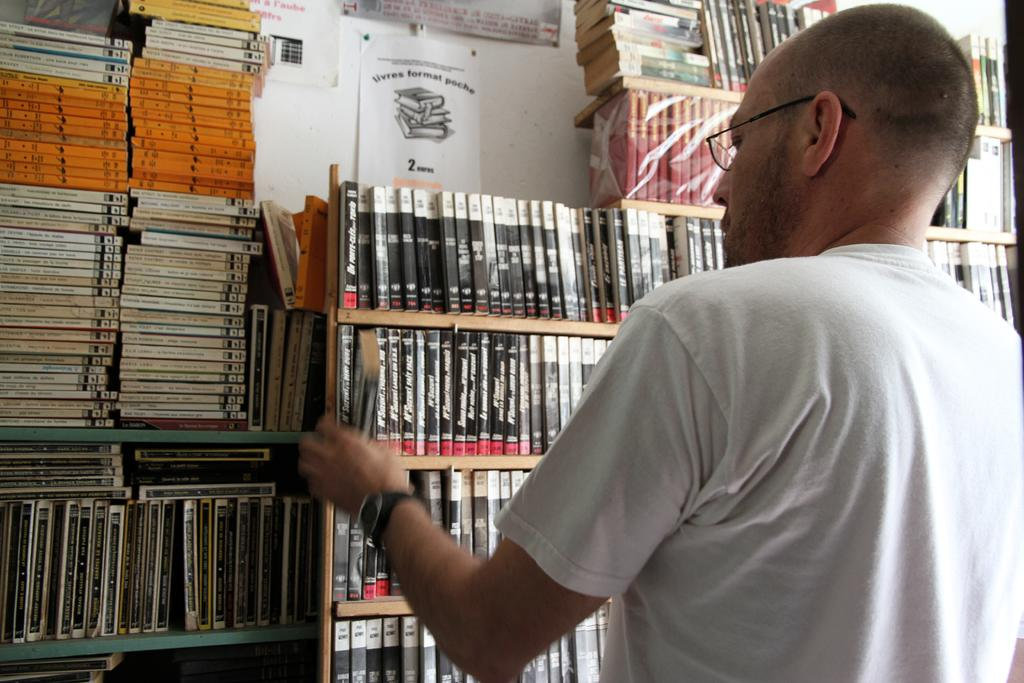Provide a one-sentence caption for the provided image. A man is browsing books in a library with a sign that has a 2 on it. 